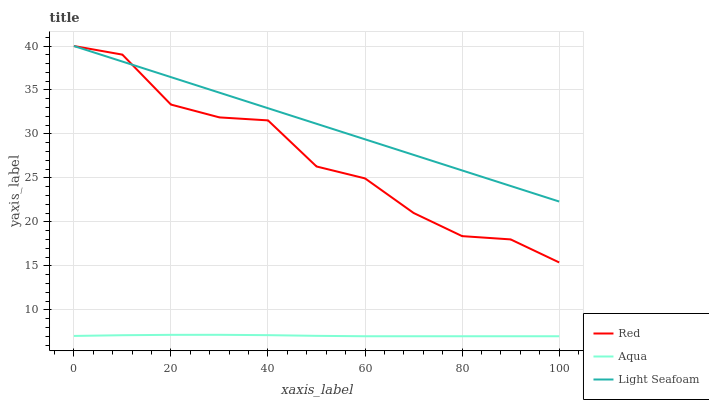Does Aqua have the minimum area under the curve?
Answer yes or no. Yes. Does Light Seafoam have the maximum area under the curve?
Answer yes or no. Yes. Does Red have the minimum area under the curve?
Answer yes or no. No. Does Red have the maximum area under the curve?
Answer yes or no. No. Is Light Seafoam the smoothest?
Answer yes or no. Yes. Is Red the roughest?
Answer yes or no. Yes. Is Aqua the smoothest?
Answer yes or no. No. Is Aqua the roughest?
Answer yes or no. No. Does Red have the lowest value?
Answer yes or no. No. Does Aqua have the highest value?
Answer yes or no. No. Is Aqua less than Light Seafoam?
Answer yes or no. Yes. Is Light Seafoam greater than Aqua?
Answer yes or no. Yes. Does Aqua intersect Light Seafoam?
Answer yes or no. No. 